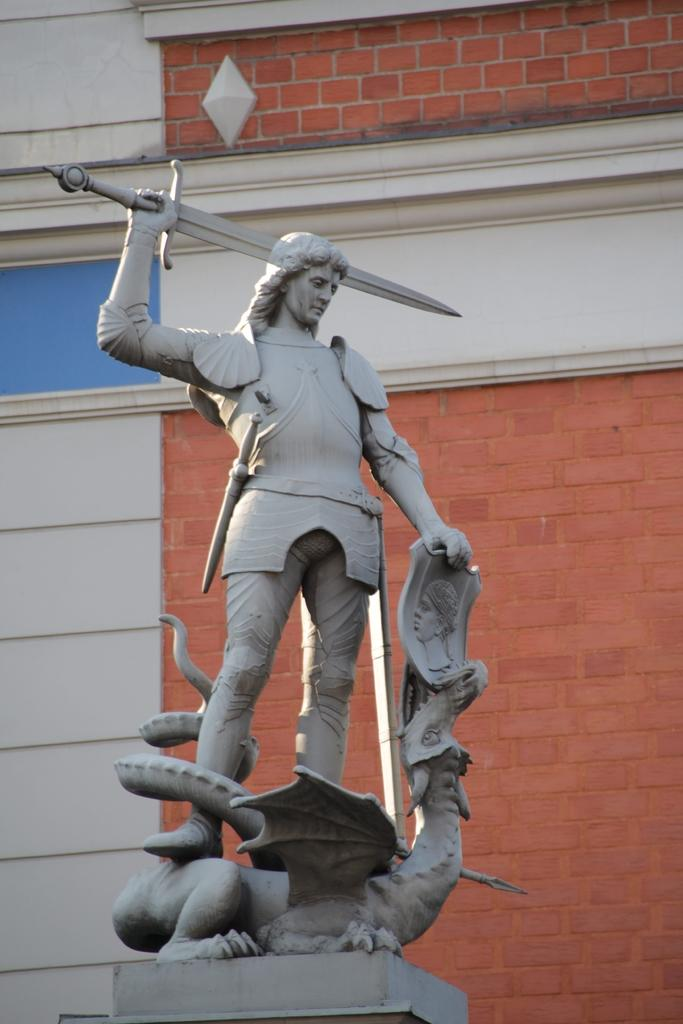What is the main subject of the image? There is a statue of a person in the image. What is the person in the statue holding? The person is holding a sword with their hand. What can be seen in the background of the image? There is a wall in the background of the image. What type of pencil can be seen in the hand of the person in the image? There is no pencil present in the image; the person is holding a sword. Can you describe the rake that is leaning against the wall in the image? There is no rake present in the image; the background only shows a wall. 